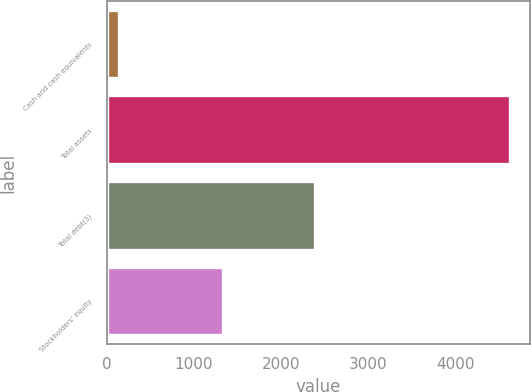Convert chart to OTSL. <chart><loc_0><loc_0><loc_500><loc_500><bar_chart><fcel>Cash and cash equivalents<fcel>Total assets<fcel>Total debt(3)<fcel>Stockholders' equity<nl><fcel>135.1<fcel>4631.2<fcel>2387<fcel>1332.4<nl></chart> 